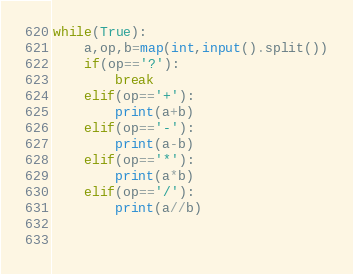Convert code to text. <code><loc_0><loc_0><loc_500><loc_500><_Python_>while(True):  
    a,op,b=map(int,input().split())
    if(op=='?'):
        break
    elif(op=='+'):
        print(a+b)
    elif(op=='-'):
        print(a-b)
    elif(op=='*'):
        print(a*b)
    elif(op=='/'):
        print(a//b)

        
</code> 